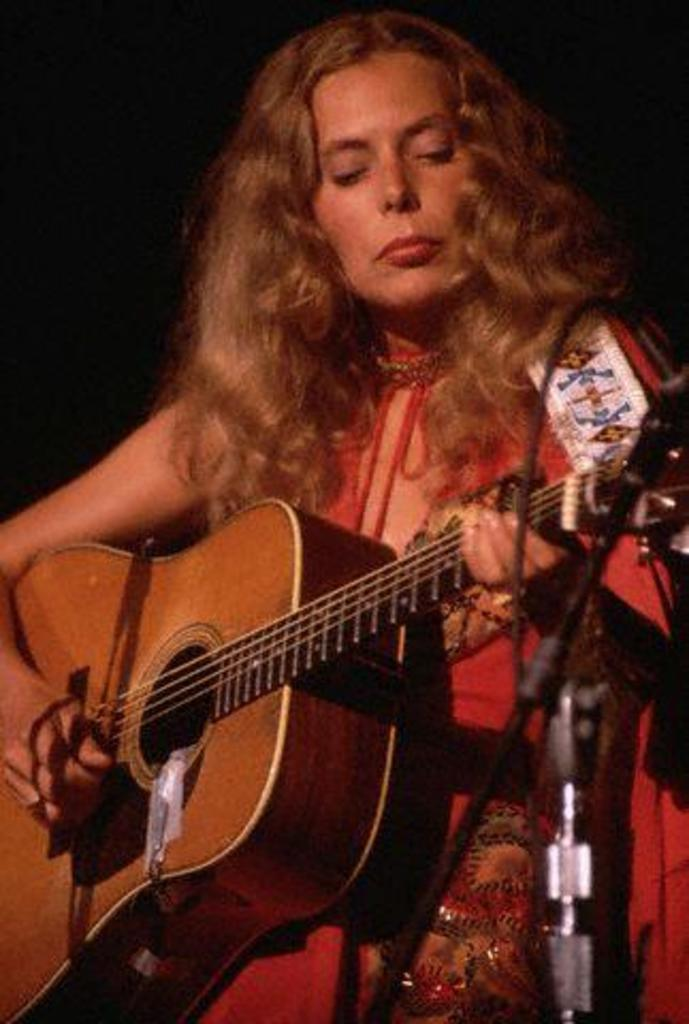Who is the main subject in the image? There is a woman in the image. What is the woman doing in the image? The woman is playing the guitar. How is the woman playing the guitar? The woman is using her hands to play the guitar. What is the woman wearing in the image? The woman is wearing a red dress. Can you hear the noise of the carriage in the image? There is no carriage present in the image, so it is not possible to hear any noise from a carriage. 